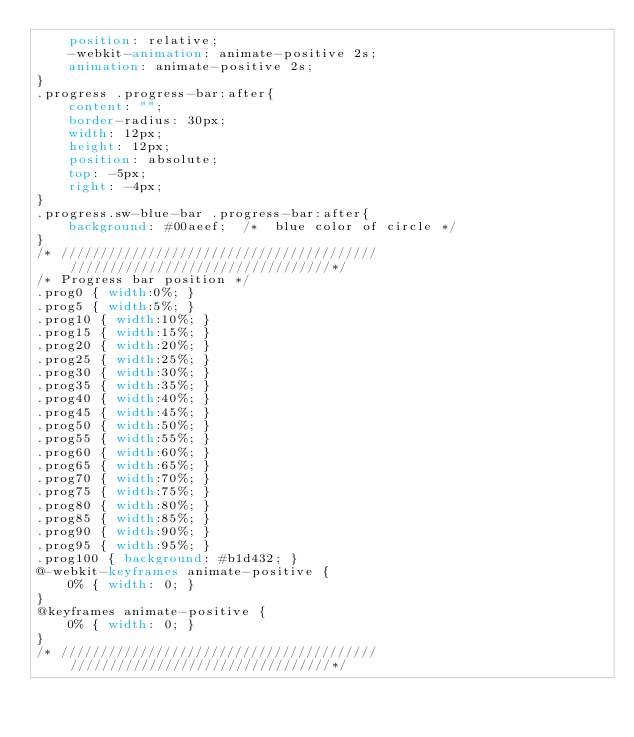<code> <loc_0><loc_0><loc_500><loc_500><_CSS_>    position: relative;
    -webkit-animation: animate-positive 2s;
    animation: animate-positive 2s;
}
.progress .progress-bar:after{
    content: "";
    border-radius: 30px;
    width: 12px;
    height: 12px;
    position: absolute;
    top: -5px;
    right: -4px;
}
.progress.sw-blue-bar .progress-bar:after{
    background: #00aeef;  /*  blue color of circle */
}
/* //////////////////////////////////////// /////////////////////////////////*/
/* Progress bar position */
.prog0 { width:0%; }
.prog5 { width:5%; }
.prog10 { width:10%; }
.prog15 { width:15%; }
.prog20 { width:20%; }
.prog25 { width:25%; }
.prog30 { width:30%; }
.prog35 { width:35%; }
.prog40 { width:40%; }
.prog45 { width:45%; }
.prog50 { width:50%; }
.prog55 { width:55%; }
.prog60 { width:60%; }
.prog65 { width:65%; }
.prog70 { width:70%; }
.prog75 { width:75%; }
.prog80 { width:80%; }
.prog85 { width:85%; }
.prog90 { width:90%; }
.prog95 { width:95%; }
.prog100 { background: #b1d432; }
@-webkit-keyframes animate-positive {
    0% { width: 0; }
}
@keyframes animate-positive {
    0% { width: 0; }
}
/* //////////////////////////////////////// /////////////////////////////////*/</code> 